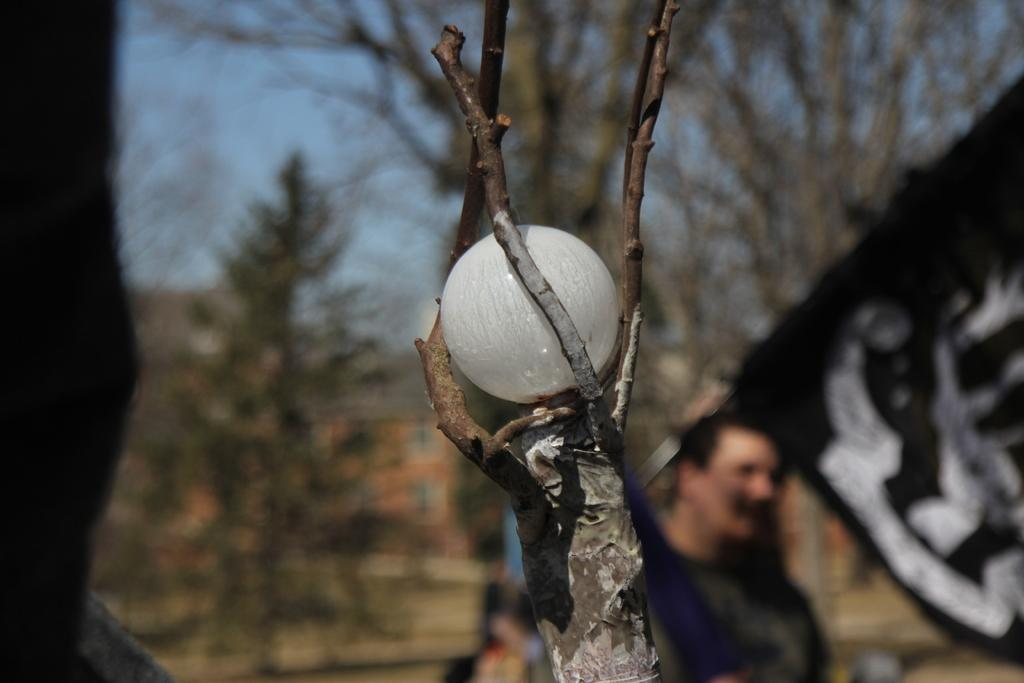What object is on the branch of the tree in the image? There is a ball on the branch of a tree in the image. What can be seen flying or waving in the image? There is a flag visible in the image. Who is present in the image? There is a man in the image. What type of vegetation is visible in the background? There is a group of trees in the background. What type of structure is visible in the background? There is a building with windows in the background. How would you describe the weather based on the image? The sky is visible and appears cloudy in the image. How many bananas are being distributed by the man in the image? There are no bananas present in the image, nor is the man distributing anything. What type of dog can be seen playing with the ball on the tree branch? There is no dog present in the image; only a ball on the branch of a tree is visible. 